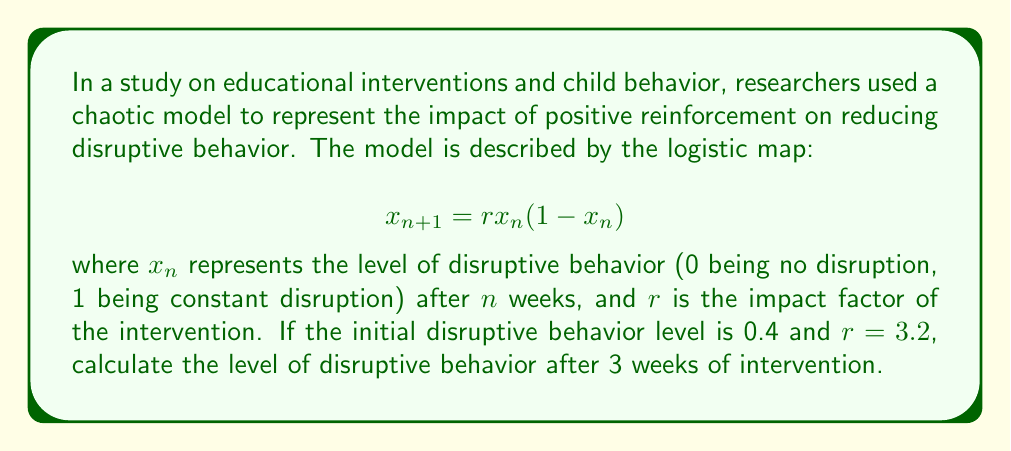What is the answer to this math problem? To solve this problem, we need to iterate the logistic map equation three times, starting with the initial condition $x_0 = 0.4$ and using $r = 3.2$. Let's go through this step-by-step:

1. First iteration (Week 1):
   $$x_1 = 3.2 \cdot 0.4 \cdot (1 - 0.4) = 3.2 \cdot 0.4 \cdot 0.6 = 0.768$$

2. Second iteration (Week 2):
   $$x_2 = 3.2 \cdot 0.768 \cdot (1 - 0.768) = 3.2 \cdot 0.768 \cdot 0.232 = 0.570982$$

3. Third iteration (Week 3):
   $$x_3 = 3.2 \cdot 0.570982 \cdot (1 - 0.570982) = 3.2 \cdot 0.570982 \cdot 0.429018 = 0.784097$$

Therefore, after 3 weeks of intervention, the level of disruptive behavior is approximately 0.784097.

This result demonstrates the non-linear and potentially counterintuitive nature of behavioral changes in response to interventions. Despite starting with a lower level of disruption and applying a consistent intervention, the model shows an increase in disruptive behavior after three weeks. This underscores the complexity of behavioral interventions and the importance of long-term, patient-centered approaches rather than punitive measures.
Answer: 0.784097 